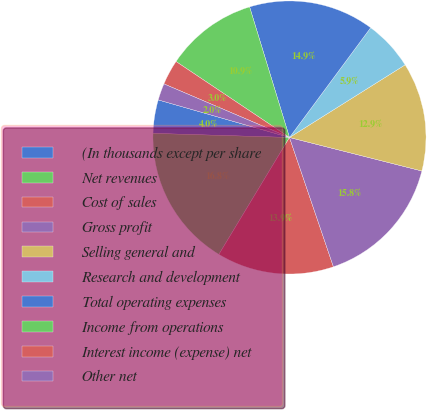Convert chart to OTSL. <chart><loc_0><loc_0><loc_500><loc_500><pie_chart><fcel>(In thousands except per share<fcel>Net revenues<fcel>Cost of sales<fcel>Gross profit<fcel>Selling general and<fcel>Research and development<fcel>Total operating expenses<fcel>Income from operations<fcel>Interest income (expense) net<fcel>Other net<nl><fcel>3.96%<fcel>16.83%<fcel>13.86%<fcel>15.84%<fcel>12.87%<fcel>5.94%<fcel>14.85%<fcel>10.89%<fcel>2.97%<fcel>1.98%<nl></chart> 